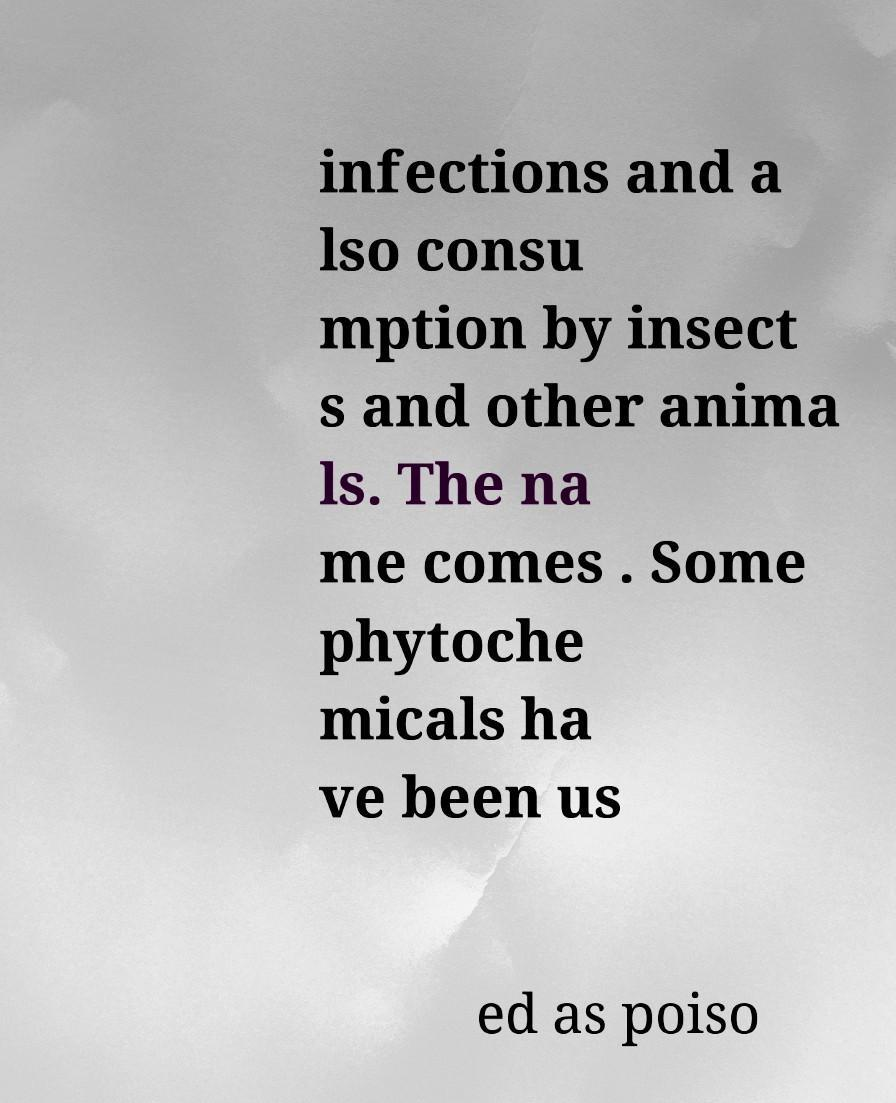Please read and relay the text visible in this image. What does it say? infections and a lso consu mption by insect s and other anima ls. The na me comes . Some phytoche micals ha ve been us ed as poiso 